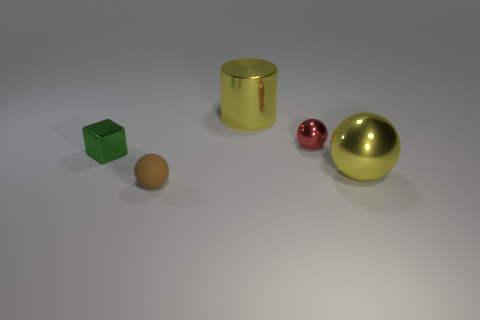Add 4 large things. How many objects exist? 9 Subtract all cylinders. How many objects are left? 4 Subtract 0 yellow cubes. How many objects are left? 5 Subtract all small spheres. Subtract all big gray metallic cylinders. How many objects are left? 3 Add 3 small red objects. How many small red objects are left? 4 Add 1 metallic cylinders. How many metallic cylinders exist? 2 